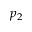Convert formula to latex. <formula><loc_0><loc_0><loc_500><loc_500>p _ { 2 }</formula> 